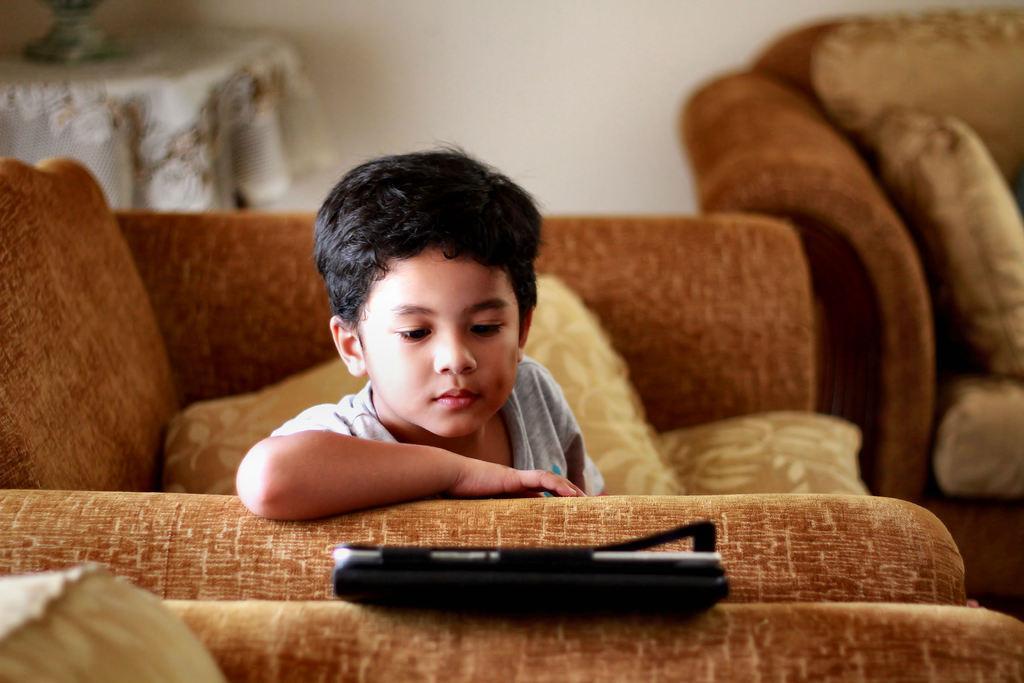Please provide a concise description of this image. This picture is clicked inside a room. In front, we see a boy in white T-shirt is lying on the sofa and he is looking into the tablet. Beside him, we see other sofa with cushions on it and behind him, we see a wall which is white in color and behind the sofa, we see a table on which white cloth is covered. 